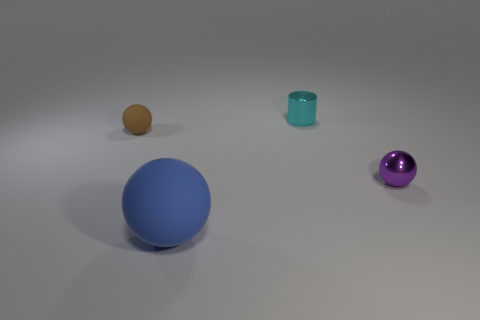Is there a tiny cylinder made of the same material as the large blue object?
Your response must be concise. No. How big is the sphere in front of the ball on the right side of the small cyan cylinder?
Ensure brevity in your answer.  Large. Is the number of brown matte balls greater than the number of red cylinders?
Ensure brevity in your answer.  Yes. There is a shiny thing that is in front of the cylinder; is it the same size as the cyan cylinder?
Ensure brevity in your answer.  Yes. Is the tiny brown rubber object the same shape as the tiny purple thing?
Offer a very short reply. Yes. Is there any other thing that has the same size as the cylinder?
Offer a terse response. Yes. There is a purple shiny thing that is the same shape as the tiny brown matte thing; what size is it?
Give a very brief answer. Small. Is the number of metallic cylinders in front of the small brown object greater than the number of things left of the purple metal sphere?
Provide a succinct answer. No. Are the large blue object and the small ball on the left side of the tiny purple ball made of the same material?
Ensure brevity in your answer.  Yes. Is there anything else that has the same shape as the big matte thing?
Provide a succinct answer. Yes. 